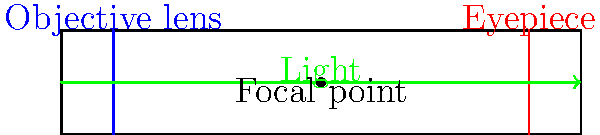As a student council president organizing an astronomy club event, you're explaining the basic structure of a refracting telescope. In the cross-sectional diagram above, what is the purpose of the blue component labeled "Objective lens"? To understand the purpose of the objective lens in a refracting telescope, let's break down its function step-by-step:

1. Light collection: The objective lens is the first optical element that incoming light encounters. Its primary purpose is to gather as much light as possible from distant celestial objects.

2. Size and placement: The objective lens is typically the largest lens in the telescope and is positioned at the front end of the telescope tube.

3. Light focusing: After collecting light, the objective lens bends (refracts) the incoming parallel light rays so that they converge at a single point called the focal point.

4. Image formation: The converging light rays form a real, inverted image of the distant object at the focal plane.

5. Magnification: The size of the objective lens determines the telescope's light-gathering power and resolution. A larger objective lens allows for better observation of fainter objects and finer details.

6. Working with the eyepiece: The objective lens works in conjunction with the eyepiece (shown in red in the diagram) to produce the final magnified image that the observer sees.

In the context of gymnastics, we can draw a parallel: just as the objective lens gathers and focuses light to create a clear image, a gymnast must gather and focus their energy and attention to execute precise movements in their routines.
Answer: To collect and focus light, forming a real image at the focal point. 